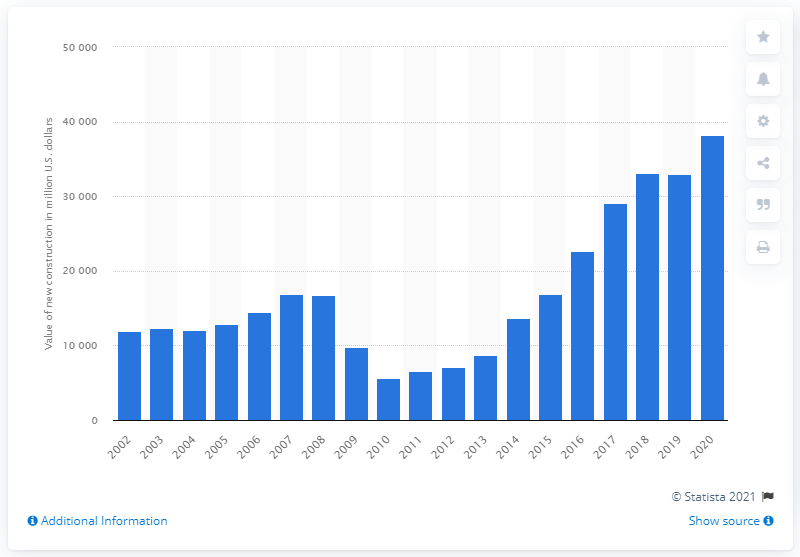Identify some key points in this picture. The value of warehouse construction in the United States between 2002 and 2020 was approximately 32,978. 